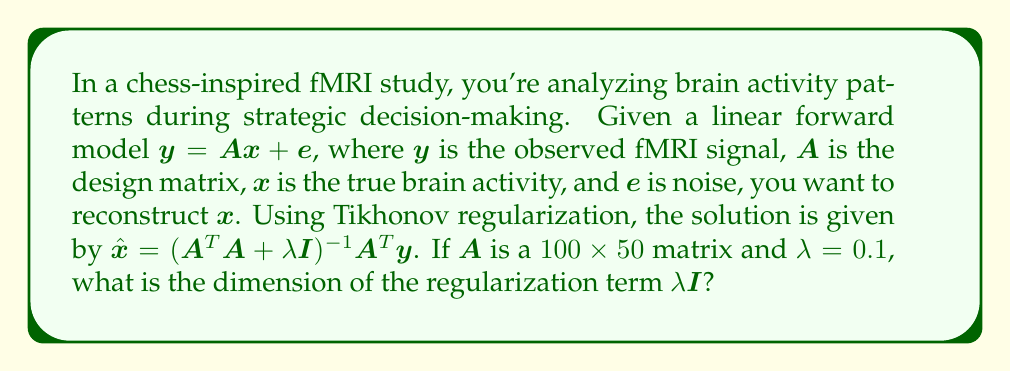Show me your answer to this math problem. To solve this problem, let's break it down step-by-step:

1) In Tikhonov regularization, we add a regularization term $\lambda\mathbf{I}$ to $\mathbf{A}^T\mathbf{A}$ to stabilize the inverse problem.

2) $\mathbf{A}$ is a $100 \times 50$ matrix. This means:
   - $\mathbf{A}^T$ is a $50 \times 100$ matrix
   - $\mathbf{A}^T\mathbf{A}$ is a $50 \times 50$ matrix

3) The regularization term $\lambda\mathbf{I}$ needs to be added to $\mathbf{A}^T\mathbf{A}$, so it must have the same dimensions as $\mathbf{A}^T\mathbf{A}$.

4) $\mathbf{I}$ represents an identity matrix, which is a square matrix with 1s on the main diagonal and 0s elsewhere.

5) Given that $\mathbf{A}^T\mathbf{A}$ is $50 \times 50$, the identity matrix $\mathbf{I}$ must also be $50 \times 50$.

6) Therefore, the regularization term $\lambda\mathbf{I}$ is a $50 \times 50$ matrix.

This dimension ensures that the matrix addition $\mathbf{A}^T\mathbf{A} + \lambda\mathbf{I}$ is mathematically valid and results in a well-conditioned matrix for inversion, allowing for a stable reconstruction of brain activity patterns.
Answer: $50 \times 50$ 